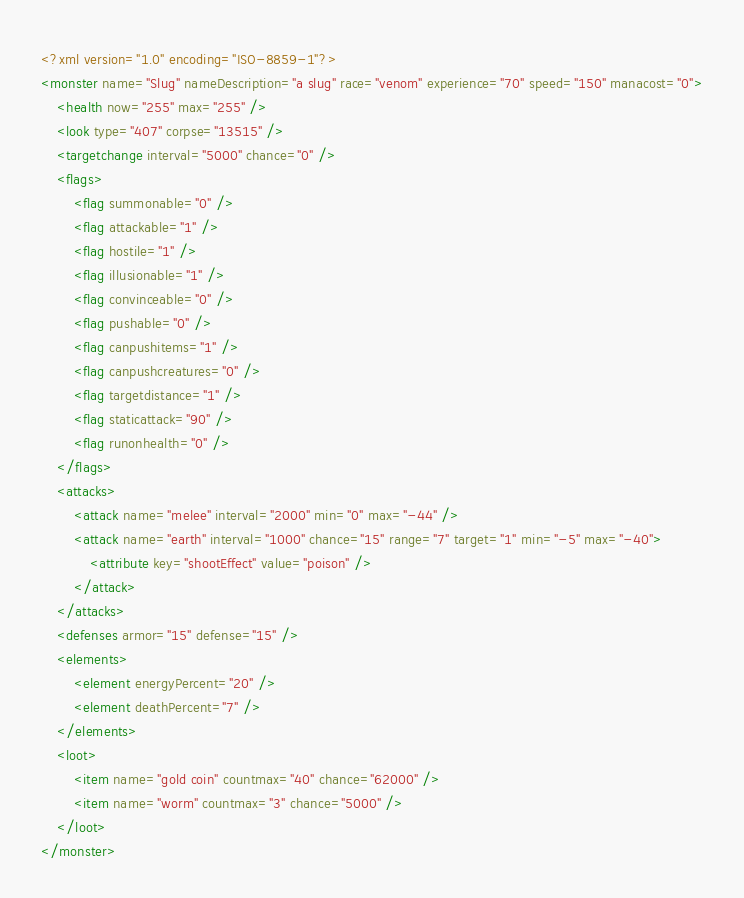Convert code to text. <code><loc_0><loc_0><loc_500><loc_500><_XML_><?xml version="1.0" encoding="ISO-8859-1"?>
<monster name="Slug" nameDescription="a slug" race="venom" experience="70" speed="150" manacost="0">
	<health now="255" max="255" />
	<look type="407" corpse="13515" />
	<targetchange interval="5000" chance="0" />
	<flags>
		<flag summonable="0" />
		<flag attackable="1" />
		<flag hostile="1" />
		<flag illusionable="1" />
		<flag convinceable="0" />
		<flag pushable="0" />
		<flag canpushitems="1" />
		<flag canpushcreatures="0" />
		<flag targetdistance="1" />
		<flag staticattack="90" />
		<flag runonhealth="0" />
	</flags>
	<attacks>
		<attack name="melee" interval="2000" min="0" max="-44" />
		<attack name="earth" interval="1000" chance="15" range="7" target="1" min="-5" max="-40">
			<attribute key="shootEffect" value="poison" />
		</attack>
	</attacks>
	<defenses armor="15" defense="15" />
	<elements>
		<element energyPercent="20" />
		<element deathPercent="7" />
	</elements>
	<loot>
		<item name="gold coin" countmax="40" chance="62000" />
		<item name="worm" countmax="3" chance="5000" />
	</loot>
</monster>
</code> 